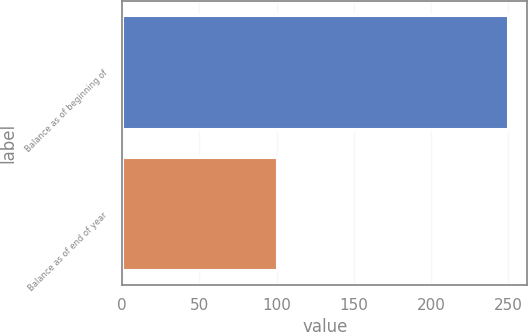Convert chart. <chart><loc_0><loc_0><loc_500><loc_500><bar_chart><fcel>Balance as of beginning of<fcel>Balance as of end of year<nl><fcel>250<fcel>100<nl></chart> 